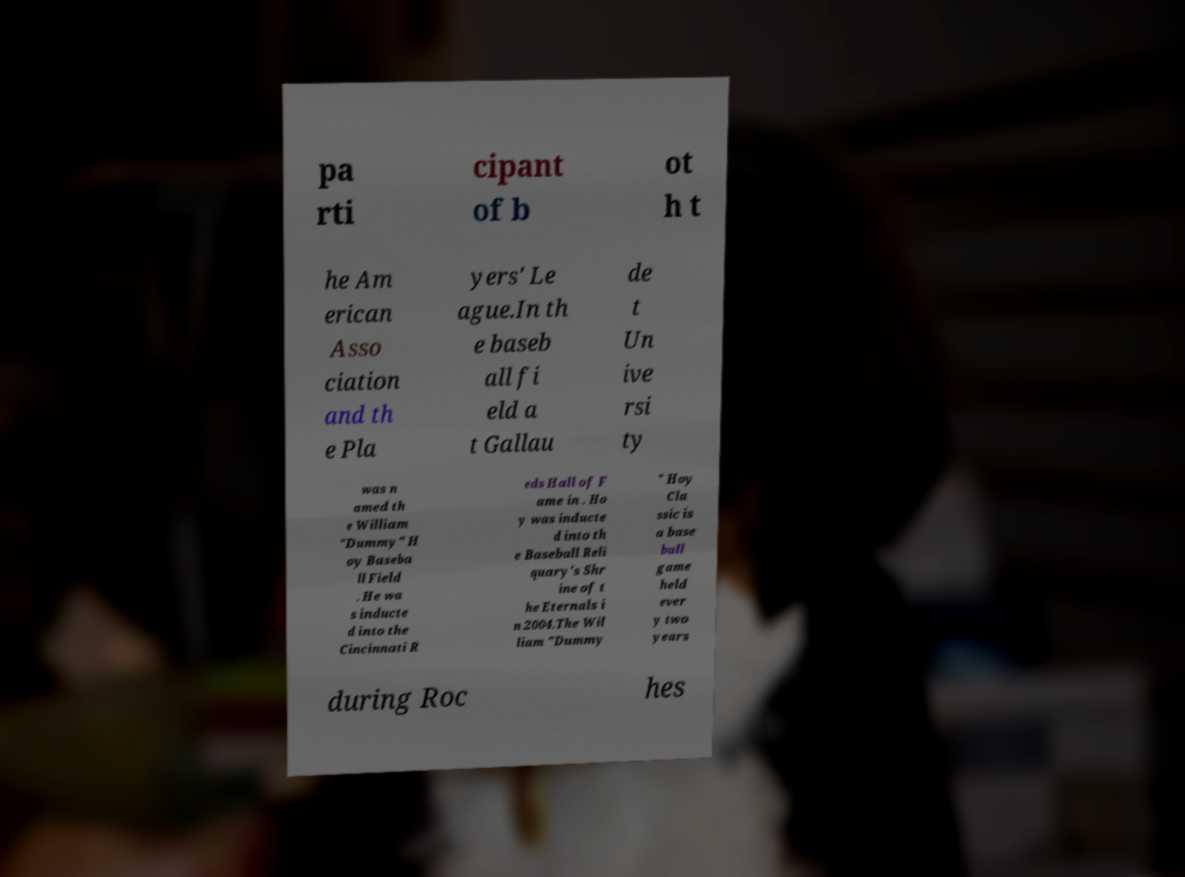What messages or text are displayed in this image? I need them in a readable, typed format. pa rti cipant of b ot h t he Am erican Asso ciation and th e Pla yers' Le ague.In th e baseb all fi eld a t Gallau de t Un ive rsi ty was n amed th e William "Dummy" H oy Baseba ll Field . He wa s inducte d into the Cincinnati R eds Hall of F ame in . Ho y was inducte d into th e Baseball Reli quary's Shr ine of t he Eternals i n 2004.The Wil liam "Dummy " Hoy Cla ssic is a base ball game held ever y two years during Roc hes 